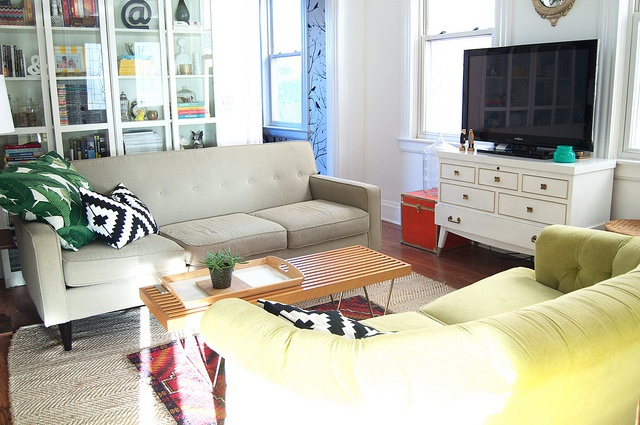Describe the objects in this image and their specific colors. I can see couch in teal, ivory, khaki, and olive tones, couch in teal, lightgray, darkgray, and gray tones, tv in teal and black tones, potted plant in teal, gray, green, and darkgray tones, and book in teal, lightblue, khaki, lightpink, and lightgray tones in this image. 